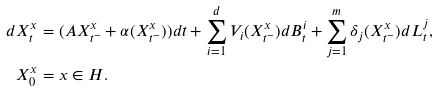Convert formula to latex. <formula><loc_0><loc_0><loc_500><loc_500>d X _ { t } ^ { x } & = ( A X ^ { x } _ { t ^ { - } } + \alpha ( X _ { t ^ { - } } ^ { x } ) ) d t + \sum _ { i = 1 } ^ { d } V _ { i } ( X _ { t ^ { - } } ^ { x } ) d B _ { t } ^ { i } + \sum _ { j = 1 } ^ { m } \delta _ { j } ( X _ { t ^ { - } } ^ { x } ) d L _ { t } ^ { j } , \\ X _ { 0 } ^ { x } & = x \in H .</formula> 